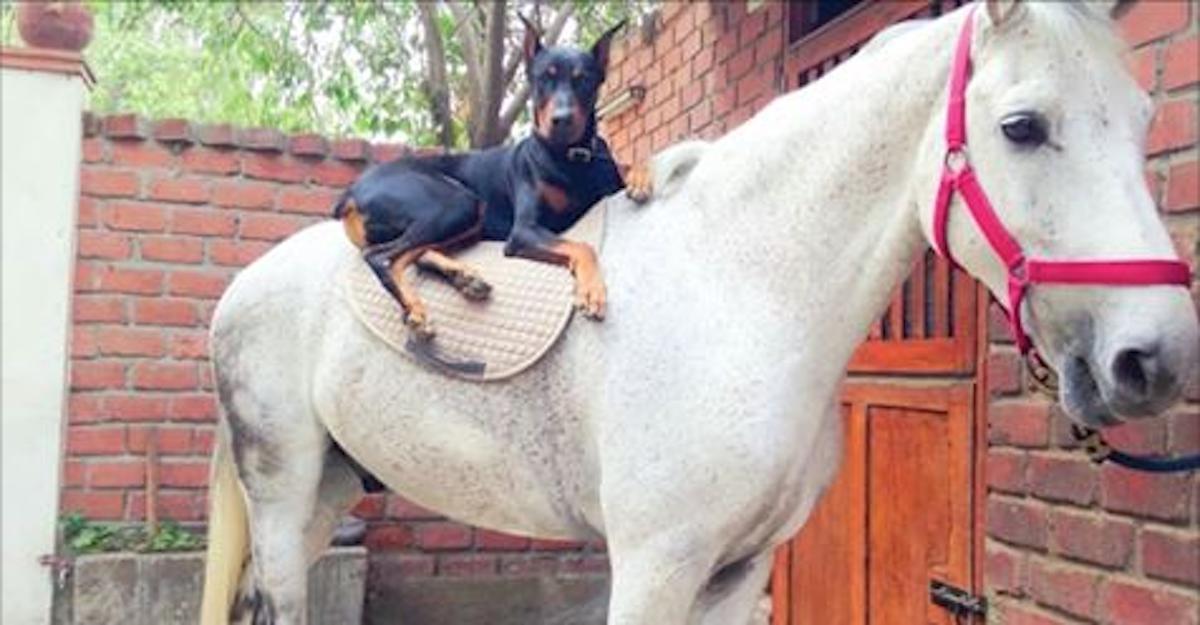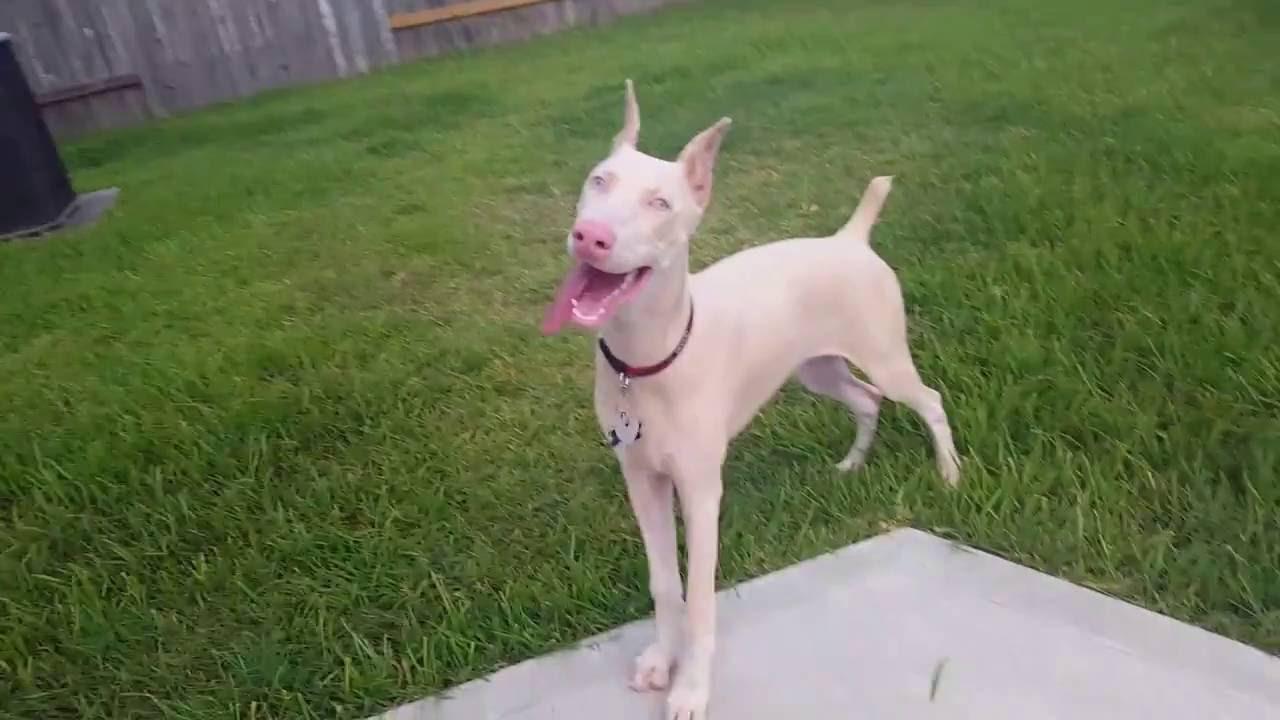The first image is the image on the left, the second image is the image on the right. For the images shown, is this caption "The ears of the dog in one of the images are down." true? Answer yes or no. No. The first image is the image on the left, the second image is the image on the right. Considering the images on both sides, is "There are two dogs with the tips of their ears pointed up" valid? Answer yes or no. Yes. 